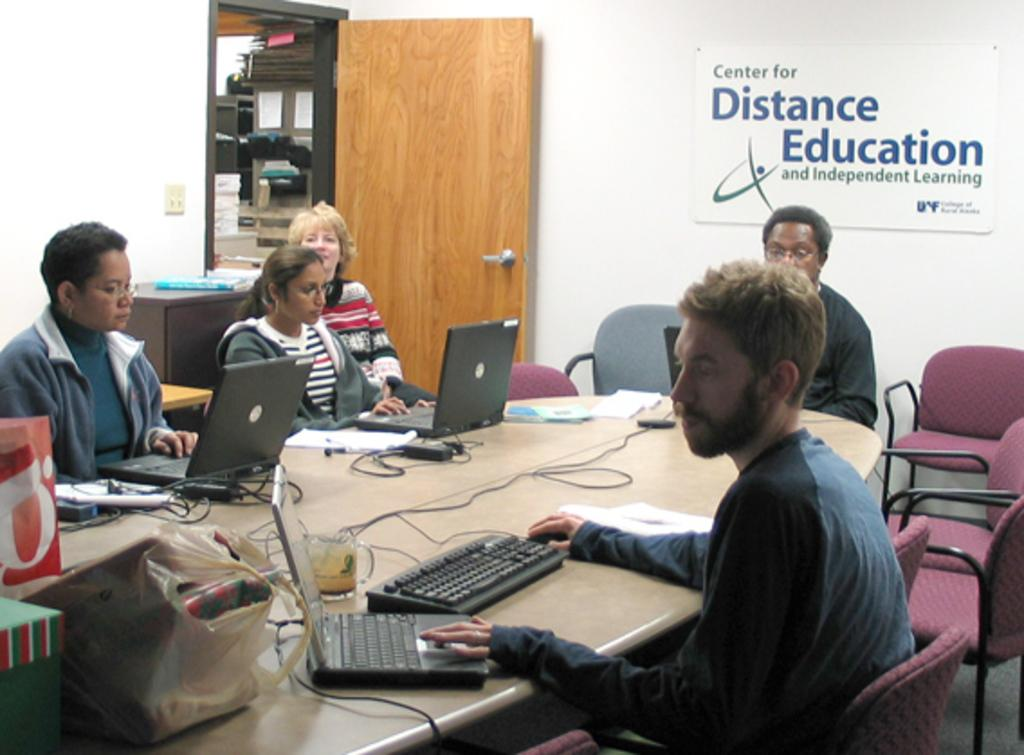<image>
Share a concise interpretation of the image provided. several people are gathered for a meeting at the center for distance education 